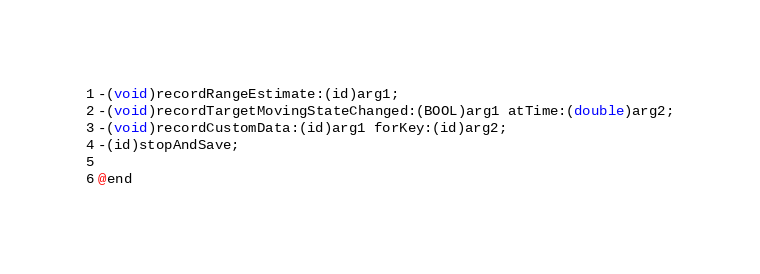<code> <loc_0><loc_0><loc_500><loc_500><_C_>-(void)recordRangeEstimate:(id)arg1;
-(void)recordTargetMovingStateChanged:(BOOL)arg1 atTime:(double)arg2;
-(void)recordCustomData:(id)arg1 forKey:(id)arg2;
-(id)stopAndSave;

@end

</code> 